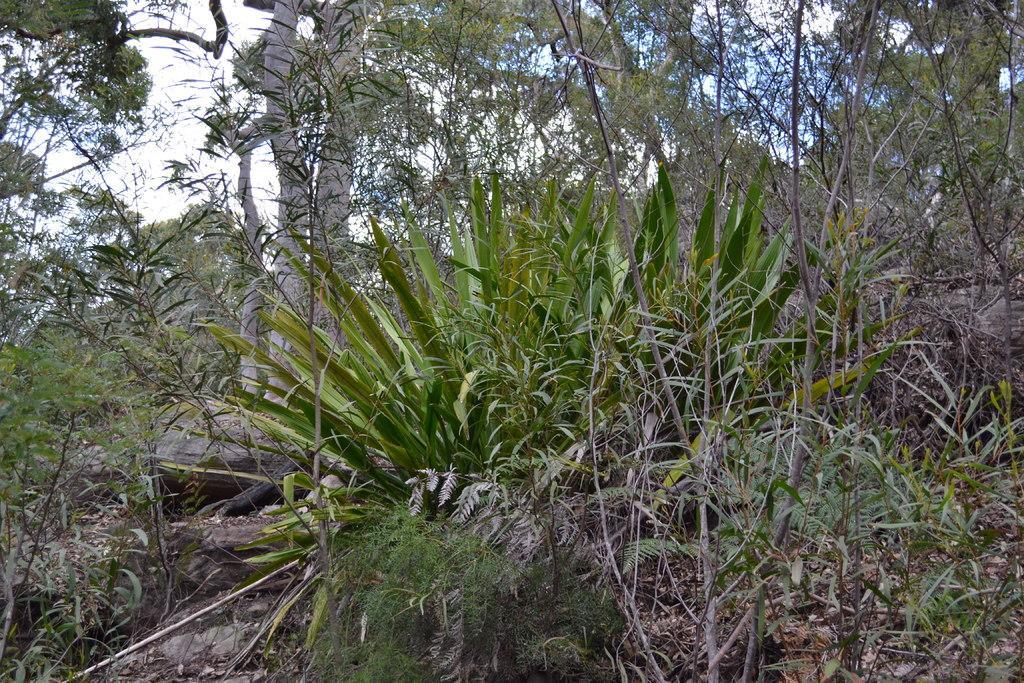Could you give a brief overview of what you see in this image? This image consists of plants and trees. At the top, there is sky. At the bottom, there is ground, on which we can see dried leaves. 